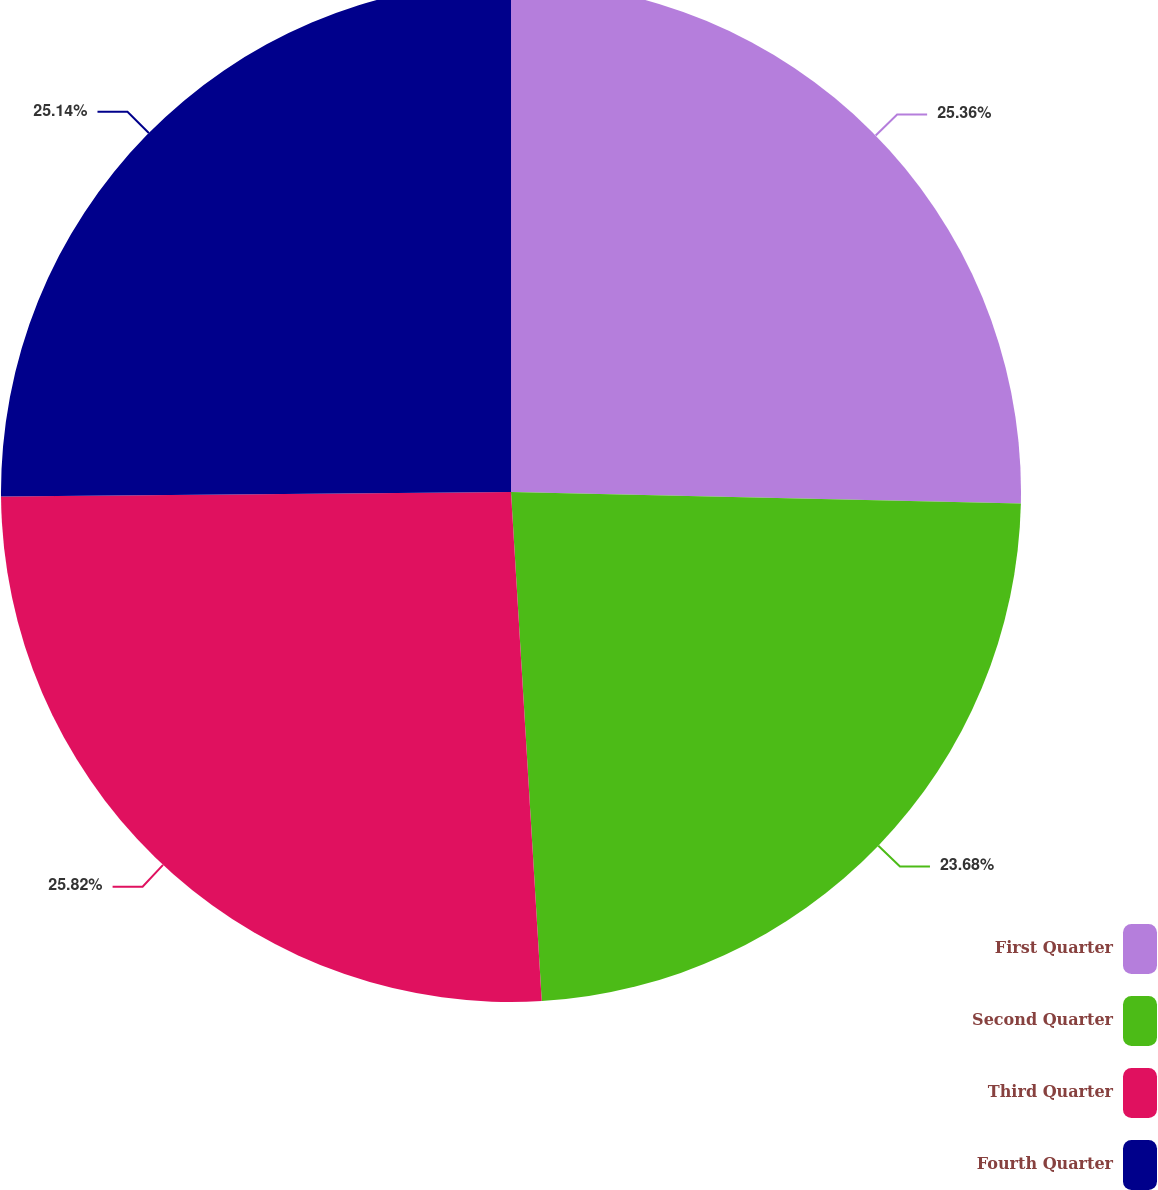Convert chart to OTSL. <chart><loc_0><loc_0><loc_500><loc_500><pie_chart><fcel>First Quarter<fcel>Second Quarter<fcel>Third Quarter<fcel>Fourth Quarter<nl><fcel>25.36%<fcel>23.68%<fcel>25.82%<fcel>25.14%<nl></chart> 